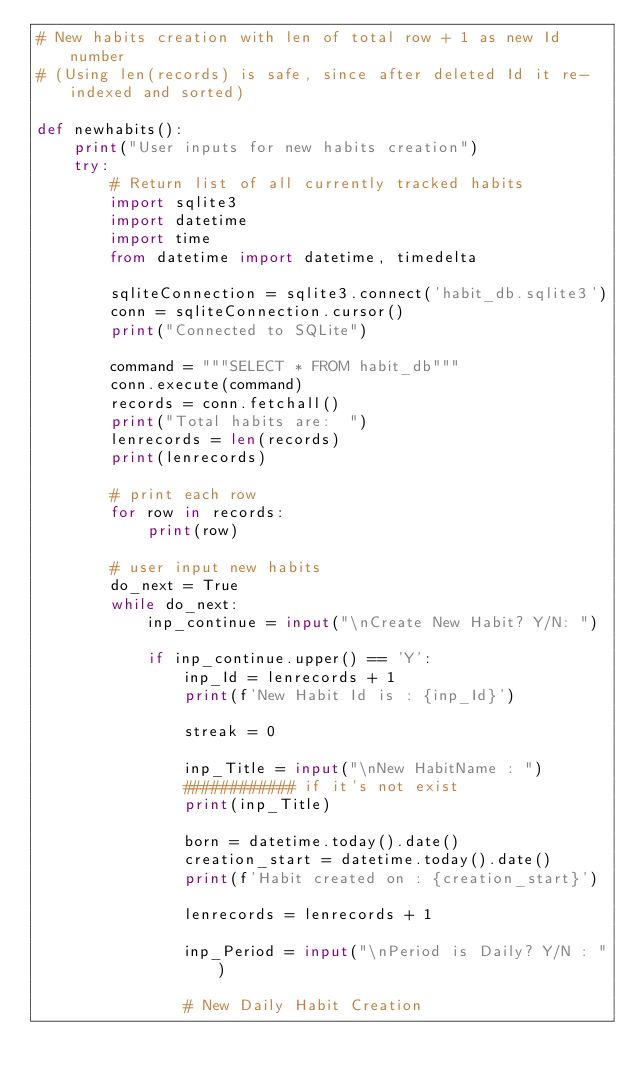<code> <loc_0><loc_0><loc_500><loc_500><_Python_># New habits creation with len of total row + 1 as new Id number
# (Using len(records) is safe, since after deleted Id it re-indexed and sorted)

def newhabits():
    print("User inputs for new habits creation")
    try:
        # Return list of all currently tracked habits
        import sqlite3
        import datetime
        import time
        from datetime import datetime, timedelta

        sqliteConnection = sqlite3.connect('habit_db.sqlite3')
        conn = sqliteConnection.cursor()
        print("Connected to SQLite")

        command = """SELECT * FROM habit_db"""
        conn.execute(command)
        records = conn.fetchall()
        print("Total habits are:  ")
        lenrecords = len(records)
        print(lenrecords)

        # print each row
        for row in records:
            print(row)

        # user input new habits
        do_next = True
        while do_next:
            inp_continue = input("\nCreate New Habit? Y/N: ")

            if inp_continue.upper() == 'Y':
                inp_Id = lenrecords + 1
                print(f'New Habit Id is : {inp_Id}')

                streak = 0

                inp_Title = input("\nNew HabitName : ")
                ############ if it's not exist
                print(inp_Title)

                born = datetime.today().date()
                creation_start = datetime.today().date()
                print(f'Habit created on : {creation_start}')

                lenrecords = lenrecords + 1

                inp_Period = input("\nPeriod is Daily? Y/N : ")

                # New Daily Habit Creation</code> 